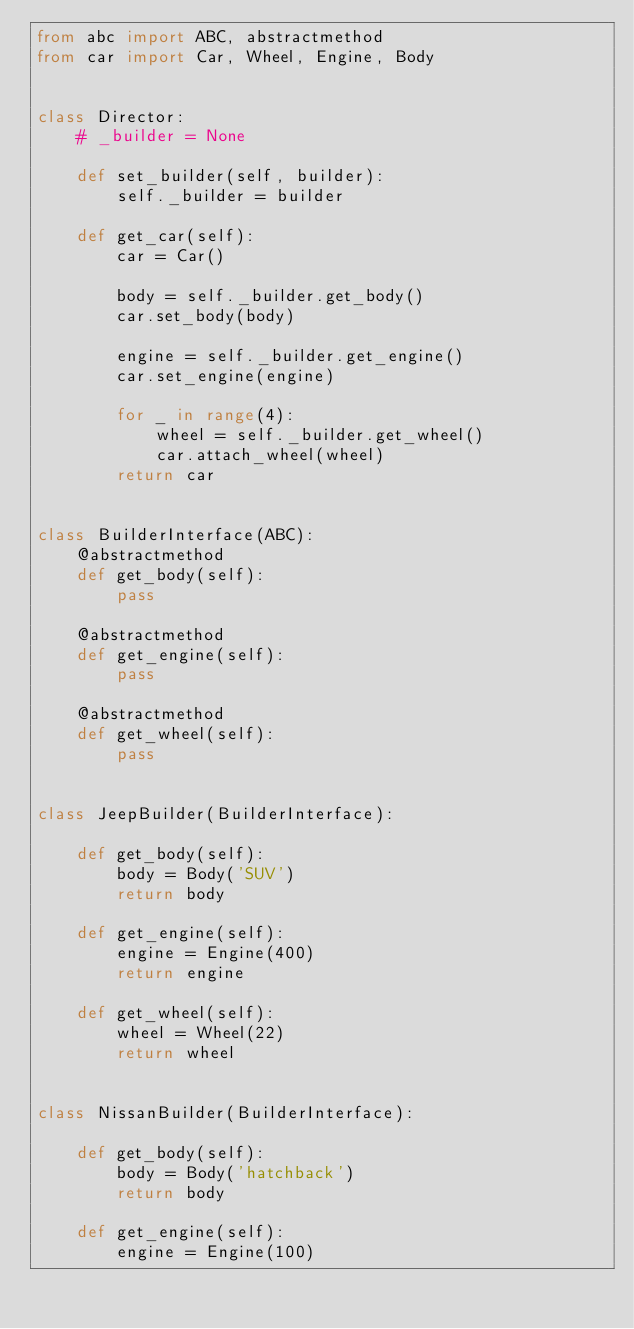<code> <loc_0><loc_0><loc_500><loc_500><_Python_>from abc import ABC, abstractmethod
from car import Car, Wheel, Engine, Body


class Director:
    # _builder = None

    def set_builder(self, builder):
        self._builder = builder

    def get_car(self):
        car = Car()

        body = self._builder.get_body()
        car.set_body(body)

        engine = self._builder.get_engine()
        car.set_engine(engine)

        for _ in range(4):
            wheel = self._builder.get_wheel()
            car.attach_wheel(wheel)
        return car


class BuilderInterface(ABC):
    @abstractmethod
    def get_body(self):
        pass

    @abstractmethod
    def get_engine(self):
        pass

    @abstractmethod
    def get_wheel(self):
        pass


class JeepBuilder(BuilderInterface):

    def get_body(self):
        body = Body('SUV')
        return body

    def get_engine(self):
        engine = Engine(400)
        return engine

    def get_wheel(self):
        wheel = Wheel(22)
        return wheel


class NissanBuilder(BuilderInterface):

    def get_body(self):
        body = Body('hatchback')
        return body

    def get_engine(self):
        engine = Engine(100)</code> 